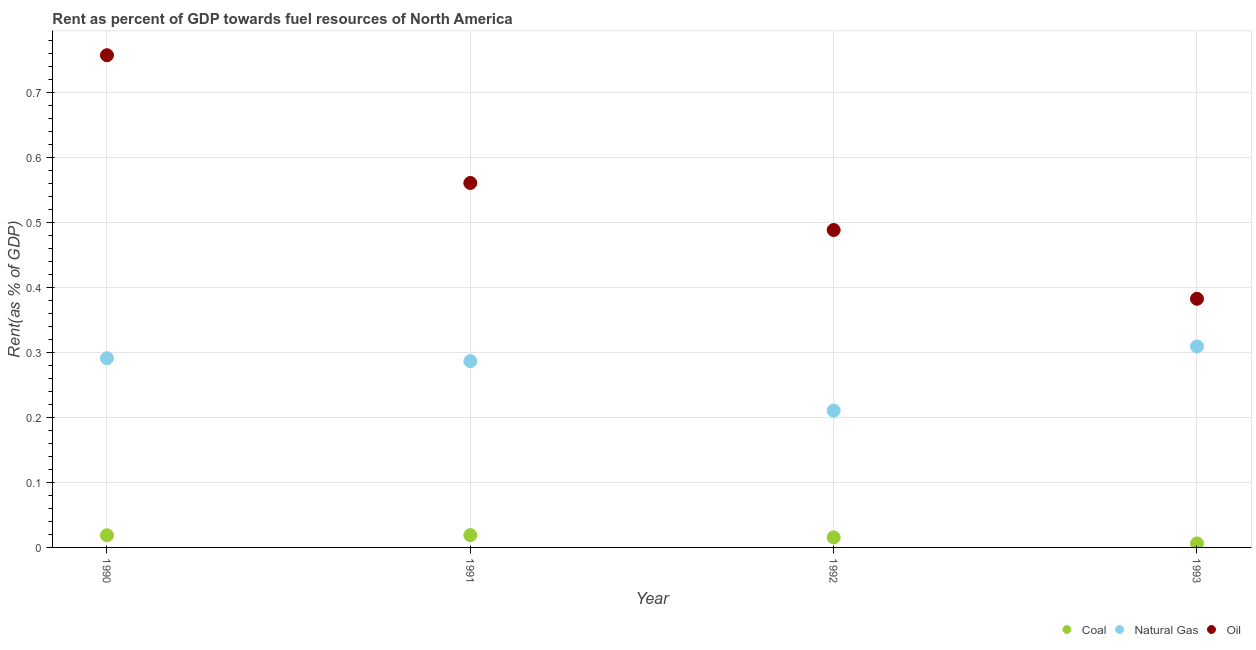How many different coloured dotlines are there?
Give a very brief answer. 3. Is the number of dotlines equal to the number of legend labels?
Provide a succinct answer. Yes. What is the rent towards natural gas in 1990?
Give a very brief answer. 0.29. Across all years, what is the maximum rent towards coal?
Give a very brief answer. 0.02. Across all years, what is the minimum rent towards oil?
Provide a succinct answer. 0.38. What is the total rent towards coal in the graph?
Your response must be concise. 0.06. What is the difference between the rent towards oil in 1990 and that in 1992?
Offer a terse response. 0.27. What is the difference between the rent towards oil in 1993 and the rent towards coal in 1991?
Offer a terse response. 0.36. What is the average rent towards natural gas per year?
Ensure brevity in your answer.  0.27. In the year 1991, what is the difference between the rent towards natural gas and rent towards oil?
Provide a succinct answer. -0.27. In how many years, is the rent towards oil greater than 0.36000000000000004 %?
Make the answer very short. 4. What is the ratio of the rent towards oil in 1990 to that in 1993?
Your response must be concise. 1.98. Is the difference between the rent towards coal in 1991 and 1993 greater than the difference between the rent towards natural gas in 1991 and 1993?
Your response must be concise. Yes. What is the difference between the highest and the second highest rent towards oil?
Your answer should be compact. 0.2. What is the difference between the highest and the lowest rent towards natural gas?
Offer a very short reply. 0.1. Is the sum of the rent towards natural gas in 1990 and 1993 greater than the maximum rent towards coal across all years?
Your answer should be very brief. Yes. Is it the case that in every year, the sum of the rent towards coal and rent towards natural gas is greater than the rent towards oil?
Provide a succinct answer. No. Is the rent towards oil strictly greater than the rent towards coal over the years?
Give a very brief answer. Yes. How many years are there in the graph?
Offer a terse response. 4. Does the graph contain any zero values?
Your answer should be very brief. No. Does the graph contain grids?
Provide a short and direct response. Yes. How are the legend labels stacked?
Provide a succinct answer. Horizontal. What is the title of the graph?
Your answer should be compact. Rent as percent of GDP towards fuel resources of North America. Does "Poland" appear as one of the legend labels in the graph?
Your response must be concise. No. What is the label or title of the X-axis?
Offer a terse response. Year. What is the label or title of the Y-axis?
Your answer should be compact. Rent(as % of GDP). What is the Rent(as % of GDP) in Coal in 1990?
Your answer should be very brief. 0.02. What is the Rent(as % of GDP) of Natural Gas in 1990?
Keep it short and to the point. 0.29. What is the Rent(as % of GDP) in Oil in 1990?
Make the answer very short. 0.76. What is the Rent(as % of GDP) in Coal in 1991?
Provide a succinct answer. 0.02. What is the Rent(as % of GDP) of Natural Gas in 1991?
Your answer should be very brief. 0.29. What is the Rent(as % of GDP) in Oil in 1991?
Provide a succinct answer. 0.56. What is the Rent(as % of GDP) in Coal in 1992?
Keep it short and to the point. 0.02. What is the Rent(as % of GDP) in Natural Gas in 1992?
Your response must be concise. 0.21. What is the Rent(as % of GDP) in Oil in 1992?
Provide a short and direct response. 0.49. What is the Rent(as % of GDP) in Coal in 1993?
Offer a terse response. 0.01. What is the Rent(as % of GDP) of Natural Gas in 1993?
Your answer should be very brief. 0.31. What is the Rent(as % of GDP) in Oil in 1993?
Ensure brevity in your answer.  0.38. Across all years, what is the maximum Rent(as % of GDP) of Coal?
Offer a very short reply. 0.02. Across all years, what is the maximum Rent(as % of GDP) in Natural Gas?
Give a very brief answer. 0.31. Across all years, what is the maximum Rent(as % of GDP) in Oil?
Your answer should be compact. 0.76. Across all years, what is the minimum Rent(as % of GDP) in Coal?
Provide a succinct answer. 0.01. Across all years, what is the minimum Rent(as % of GDP) in Natural Gas?
Give a very brief answer. 0.21. Across all years, what is the minimum Rent(as % of GDP) of Oil?
Make the answer very short. 0.38. What is the total Rent(as % of GDP) in Coal in the graph?
Keep it short and to the point. 0.06. What is the total Rent(as % of GDP) of Natural Gas in the graph?
Provide a short and direct response. 1.1. What is the total Rent(as % of GDP) in Oil in the graph?
Give a very brief answer. 2.19. What is the difference between the Rent(as % of GDP) of Coal in 1990 and that in 1991?
Offer a very short reply. -0. What is the difference between the Rent(as % of GDP) in Natural Gas in 1990 and that in 1991?
Your response must be concise. 0. What is the difference between the Rent(as % of GDP) of Oil in 1990 and that in 1991?
Keep it short and to the point. 0.2. What is the difference between the Rent(as % of GDP) of Coal in 1990 and that in 1992?
Your response must be concise. 0. What is the difference between the Rent(as % of GDP) of Natural Gas in 1990 and that in 1992?
Offer a very short reply. 0.08. What is the difference between the Rent(as % of GDP) of Oil in 1990 and that in 1992?
Your answer should be very brief. 0.27. What is the difference between the Rent(as % of GDP) of Coal in 1990 and that in 1993?
Provide a succinct answer. 0.01. What is the difference between the Rent(as % of GDP) in Natural Gas in 1990 and that in 1993?
Offer a very short reply. -0.02. What is the difference between the Rent(as % of GDP) of Oil in 1990 and that in 1993?
Keep it short and to the point. 0.37. What is the difference between the Rent(as % of GDP) of Coal in 1991 and that in 1992?
Provide a short and direct response. 0. What is the difference between the Rent(as % of GDP) of Natural Gas in 1991 and that in 1992?
Your answer should be very brief. 0.08. What is the difference between the Rent(as % of GDP) of Oil in 1991 and that in 1992?
Make the answer very short. 0.07. What is the difference between the Rent(as % of GDP) in Coal in 1991 and that in 1993?
Give a very brief answer. 0.01. What is the difference between the Rent(as % of GDP) in Natural Gas in 1991 and that in 1993?
Provide a succinct answer. -0.02. What is the difference between the Rent(as % of GDP) in Oil in 1991 and that in 1993?
Your answer should be compact. 0.18. What is the difference between the Rent(as % of GDP) in Coal in 1992 and that in 1993?
Ensure brevity in your answer.  0.01. What is the difference between the Rent(as % of GDP) of Natural Gas in 1992 and that in 1993?
Provide a short and direct response. -0.1. What is the difference between the Rent(as % of GDP) of Oil in 1992 and that in 1993?
Offer a terse response. 0.11. What is the difference between the Rent(as % of GDP) of Coal in 1990 and the Rent(as % of GDP) of Natural Gas in 1991?
Your answer should be compact. -0.27. What is the difference between the Rent(as % of GDP) of Coal in 1990 and the Rent(as % of GDP) of Oil in 1991?
Ensure brevity in your answer.  -0.54. What is the difference between the Rent(as % of GDP) in Natural Gas in 1990 and the Rent(as % of GDP) in Oil in 1991?
Your answer should be compact. -0.27. What is the difference between the Rent(as % of GDP) in Coal in 1990 and the Rent(as % of GDP) in Natural Gas in 1992?
Your answer should be compact. -0.19. What is the difference between the Rent(as % of GDP) in Coal in 1990 and the Rent(as % of GDP) in Oil in 1992?
Your response must be concise. -0.47. What is the difference between the Rent(as % of GDP) of Natural Gas in 1990 and the Rent(as % of GDP) of Oil in 1992?
Provide a succinct answer. -0.2. What is the difference between the Rent(as % of GDP) in Coal in 1990 and the Rent(as % of GDP) in Natural Gas in 1993?
Your answer should be very brief. -0.29. What is the difference between the Rent(as % of GDP) of Coal in 1990 and the Rent(as % of GDP) of Oil in 1993?
Keep it short and to the point. -0.36. What is the difference between the Rent(as % of GDP) in Natural Gas in 1990 and the Rent(as % of GDP) in Oil in 1993?
Your answer should be compact. -0.09. What is the difference between the Rent(as % of GDP) in Coal in 1991 and the Rent(as % of GDP) in Natural Gas in 1992?
Keep it short and to the point. -0.19. What is the difference between the Rent(as % of GDP) in Coal in 1991 and the Rent(as % of GDP) in Oil in 1992?
Keep it short and to the point. -0.47. What is the difference between the Rent(as % of GDP) in Natural Gas in 1991 and the Rent(as % of GDP) in Oil in 1992?
Ensure brevity in your answer.  -0.2. What is the difference between the Rent(as % of GDP) in Coal in 1991 and the Rent(as % of GDP) in Natural Gas in 1993?
Ensure brevity in your answer.  -0.29. What is the difference between the Rent(as % of GDP) of Coal in 1991 and the Rent(as % of GDP) of Oil in 1993?
Offer a very short reply. -0.36. What is the difference between the Rent(as % of GDP) of Natural Gas in 1991 and the Rent(as % of GDP) of Oil in 1993?
Give a very brief answer. -0.1. What is the difference between the Rent(as % of GDP) of Coal in 1992 and the Rent(as % of GDP) of Natural Gas in 1993?
Your answer should be very brief. -0.29. What is the difference between the Rent(as % of GDP) in Coal in 1992 and the Rent(as % of GDP) in Oil in 1993?
Give a very brief answer. -0.37. What is the difference between the Rent(as % of GDP) in Natural Gas in 1992 and the Rent(as % of GDP) in Oil in 1993?
Give a very brief answer. -0.17. What is the average Rent(as % of GDP) in Coal per year?
Give a very brief answer. 0.01. What is the average Rent(as % of GDP) of Natural Gas per year?
Your answer should be compact. 0.27. What is the average Rent(as % of GDP) of Oil per year?
Ensure brevity in your answer.  0.55. In the year 1990, what is the difference between the Rent(as % of GDP) of Coal and Rent(as % of GDP) of Natural Gas?
Make the answer very short. -0.27. In the year 1990, what is the difference between the Rent(as % of GDP) of Coal and Rent(as % of GDP) of Oil?
Your answer should be very brief. -0.74. In the year 1990, what is the difference between the Rent(as % of GDP) of Natural Gas and Rent(as % of GDP) of Oil?
Provide a short and direct response. -0.47. In the year 1991, what is the difference between the Rent(as % of GDP) of Coal and Rent(as % of GDP) of Natural Gas?
Offer a very short reply. -0.27. In the year 1991, what is the difference between the Rent(as % of GDP) of Coal and Rent(as % of GDP) of Oil?
Provide a succinct answer. -0.54. In the year 1991, what is the difference between the Rent(as % of GDP) of Natural Gas and Rent(as % of GDP) of Oil?
Give a very brief answer. -0.27. In the year 1992, what is the difference between the Rent(as % of GDP) in Coal and Rent(as % of GDP) in Natural Gas?
Your answer should be very brief. -0.2. In the year 1992, what is the difference between the Rent(as % of GDP) of Coal and Rent(as % of GDP) of Oil?
Your answer should be very brief. -0.47. In the year 1992, what is the difference between the Rent(as % of GDP) in Natural Gas and Rent(as % of GDP) in Oil?
Provide a succinct answer. -0.28. In the year 1993, what is the difference between the Rent(as % of GDP) of Coal and Rent(as % of GDP) of Natural Gas?
Provide a succinct answer. -0.3. In the year 1993, what is the difference between the Rent(as % of GDP) in Coal and Rent(as % of GDP) in Oil?
Offer a very short reply. -0.38. In the year 1993, what is the difference between the Rent(as % of GDP) of Natural Gas and Rent(as % of GDP) of Oil?
Keep it short and to the point. -0.07. What is the ratio of the Rent(as % of GDP) in Coal in 1990 to that in 1991?
Provide a short and direct response. 0.99. What is the ratio of the Rent(as % of GDP) of Natural Gas in 1990 to that in 1991?
Give a very brief answer. 1.02. What is the ratio of the Rent(as % of GDP) in Oil in 1990 to that in 1991?
Your response must be concise. 1.35. What is the ratio of the Rent(as % of GDP) in Coal in 1990 to that in 1992?
Offer a very short reply. 1.21. What is the ratio of the Rent(as % of GDP) in Natural Gas in 1990 to that in 1992?
Offer a very short reply. 1.38. What is the ratio of the Rent(as % of GDP) of Oil in 1990 to that in 1992?
Your answer should be very brief. 1.55. What is the ratio of the Rent(as % of GDP) in Coal in 1990 to that in 1993?
Provide a succinct answer. 3.03. What is the ratio of the Rent(as % of GDP) in Natural Gas in 1990 to that in 1993?
Your response must be concise. 0.94. What is the ratio of the Rent(as % of GDP) of Oil in 1990 to that in 1993?
Provide a succinct answer. 1.98. What is the ratio of the Rent(as % of GDP) of Coal in 1991 to that in 1992?
Give a very brief answer. 1.22. What is the ratio of the Rent(as % of GDP) of Natural Gas in 1991 to that in 1992?
Make the answer very short. 1.36. What is the ratio of the Rent(as % of GDP) of Oil in 1991 to that in 1992?
Offer a very short reply. 1.15. What is the ratio of the Rent(as % of GDP) of Coal in 1991 to that in 1993?
Offer a very short reply. 3.07. What is the ratio of the Rent(as % of GDP) in Natural Gas in 1991 to that in 1993?
Offer a very short reply. 0.93. What is the ratio of the Rent(as % of GDP) in Oil in 1991 to that in 1993?
Offer a terse response. 1.47. What is the ratio of the Rent(as % of GDP) in Coal in 1992 to that in 1993?
Offer a terse response. 2.51. What is the ratio of the Rent(as % of GDP) of Natural Gas in 1992 to that in 1993?
Keep it short and to the point. 0.68. What is the ratio of the Rent(as % of GDP) in Oil in 1992 to that in 1993?
Provide a short and direct response. 1.28. What is the difference between the highest and the second highest Rent(as % of GDP) of Coal?
Make the answer very short. 0. What is the difference between the highest and the second highest Rent(as % of GDP) in Natural Gas?
Make the answer very short. 0.02. What is the difference between the highest and the second highest Rent(as % of GDP) of Oil?
Keep it short and to the point. 0.2. What is the difference between the highest and the lowest Rent(as % of GDP) of Coal?
Make the answer very short. 0.01. What is the difference between the highest and the lowest Rent(as % of GDP) in Natural Gas?
Offer a very short reply. 0.1. What is the difference between the highest and the lowest Rent(as % of GDP) in Oil?
Ensure brevity in your answer.  0.37. 